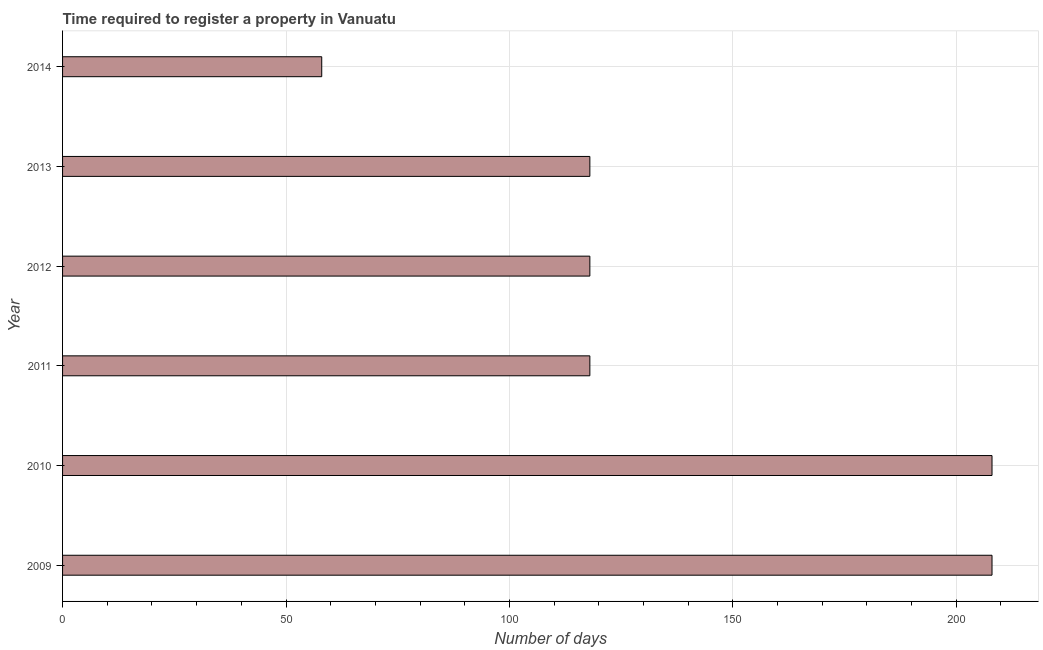Does the graph contain grids?
Offer a terse response. Yes. What is the title of the graph?
Your answer should be compact. Time required to register a property in Vanuatu. What is the label or title of the X-axis?
Your answer should be compact. Number of days. What is the label or title of the Y-axis?
Offer a very short reply. Year. What is the number of days required to register property in 2013?
Provide a short and direct response. 118. Across all years, what is the maximum number of days required to register property?
Provide a short and direct response. 208. Across all years, what is the minimum number of days required to register property?
Give a very brief answer. 58. What is the sum of the number of days required to register property?
Keep it short and to the point. 828. What is the average number of days required to register property per year?
Provide a short and direct response. 138. What is the median number of days required to register property?
Your response must be concise. 118. In how many years, is the number of days required to register property greater than 10 days?
Offer a terse response. 6. What is the ratio of the number of days required to register property in 2009 to that in 2010?
Your answer should be very brief. 1. Is the number of days required to register property in 2010 less than that in 2013?
Ensure brevity in your answer.  No. Is the difference between the number of days required to register property in 2009 and 2013 greater than the difference between any two years?
Give a very brief answer. No. What is the difference between the highest and the lowest number of days required to register property?
Ensure brevity in your answer.  150. In how many years, is the number of days required to register property greater than the average number of days required to register property taken over all years?
Provide a short and direct response. 2. How many bars are there?
Ensure brevity in your answer.  6. Are all the bars in the graph horizontal?
Provide a succinct answer. Yes. How many years are there in the graph?
Make the answer very short. 6. What is the Number of days of 2009?
Make the answer very short. 208. What is the Number of days of 2010?
Your response must be concise. 208. What is the Number of days in 2011?
Your response must be concise. 118. What is the Number of days in 2012?
Ensure brevity in your answer.  118. What is the Number of days in 2013?
Your response must be concise. 118. What is the difference between the Number of days in 2009 and 2014?
Offer a very short reply. 150. What is the difference between the Number of days in 2010 and 2012?
Offer a very short reply. 90. What is the difference between the Number of days in 2010 and 2014?
Your answer should be very brief. 150. What is the difference between the Number of days in 2011 and 2013?
Provide a succinct answer. 0. What is the difference between the Number of days in 2011 and 2014?
Ensure brevity in your answer.  60. What is the difference between the Number of days in 2012 and 2013?
Ensure brevity in your answer.  0. What is the difference between the Number of days in 2012 and 2014?
Your response must be concise. 60. What is the ratio of the Number of days in 2009 to that in 2010?
Your response must be concise. 1. What is the ratio of the Number of days in 2009 to that in 2011?
Your answer should be compact. 1.76. What is the ratio of the Number of days in 2009 to that in 2012?
Give a very brief answer. 1.76. What is the ratio of the Number of days in 2009 to that in 2013?
Offer a very short reply. 1.76. What is the ratio of the Number of days in 2009 to that in 2014?
Your response must be concise. 3.59. What is the ratio of the Number of days in 2010 to that in 2011?
Offer a terse response. 1.76. What is the ratio of the Number of days in 2010 to that in 2012?
Your answer should be very brief. 1.76. What is the ratio of the Number of days in 2010 to that in 2013?
Your response must be concise. 1.76. What is the ratio of the Number of days in 2010 to that in 2014?
Your answer should be very brief. 3.59. What is the ratio of the Number of days in 2011 to that in 2013?
Provide a short and direct response. 1. What is the ratio of the Number of days in 2011 to that in 2014?
Provide a succinct answer. 2.03. What is the ratio of the Number of days in 2012 to that in 2013?
Your answer should be very brief. 1. What is the ratio of the Number of days in 2012 to that in 2014?
Ensure brevity in your answer.  2.03. What is the ratio of the Number of days in 2013 to that in 2014?
Your answer should be very brief. 2.03. 